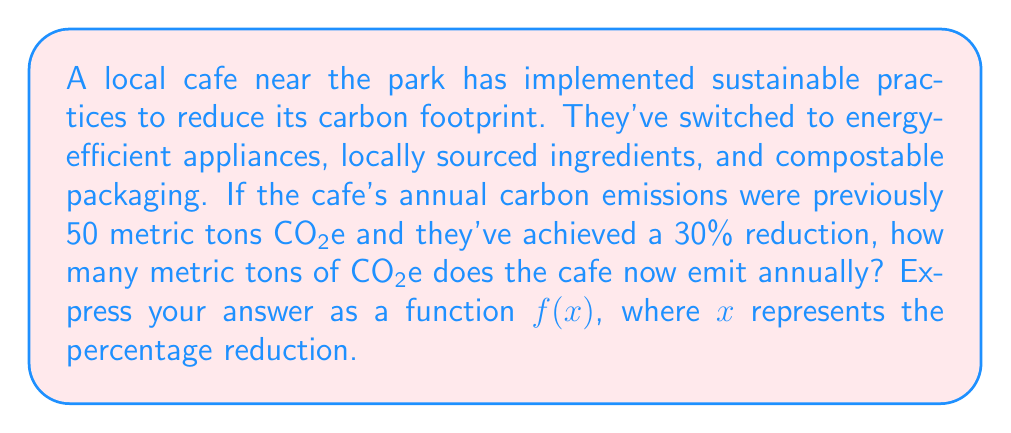Help me with this question. Let's approach this step-by-step:

1) First, we need to understand what the function f(x) represents:
   f(x) = new annual emissions after x% reduction

2) We know the initial emissions were 50 metric tons CO2e.

3) To calculate the new emissions after a percentage reduction, we use the formula:
   New value = Original value * (1 - Percentage reduction)

4) In function notation, this becomes:
   f(x) = 50 * (1 - x/100)

5) Simplifying:
   f(x) = 50 - 0.5x

6) This function f(x) will give us the new annual emissions for any percentage reduction x.

7) To check our work, we can calculate for the given 30% reduction:
   f(30) = 50 - 0.5(30) = 50 - 15 = 35 metric tons CO2e

Therefore, the function f(x) = 50 - 0.5x represents the cafe's new annual carbon emissions in metric tons CO2e after an x% reduction.
Answer: f(x) = 50 - 0.5x 